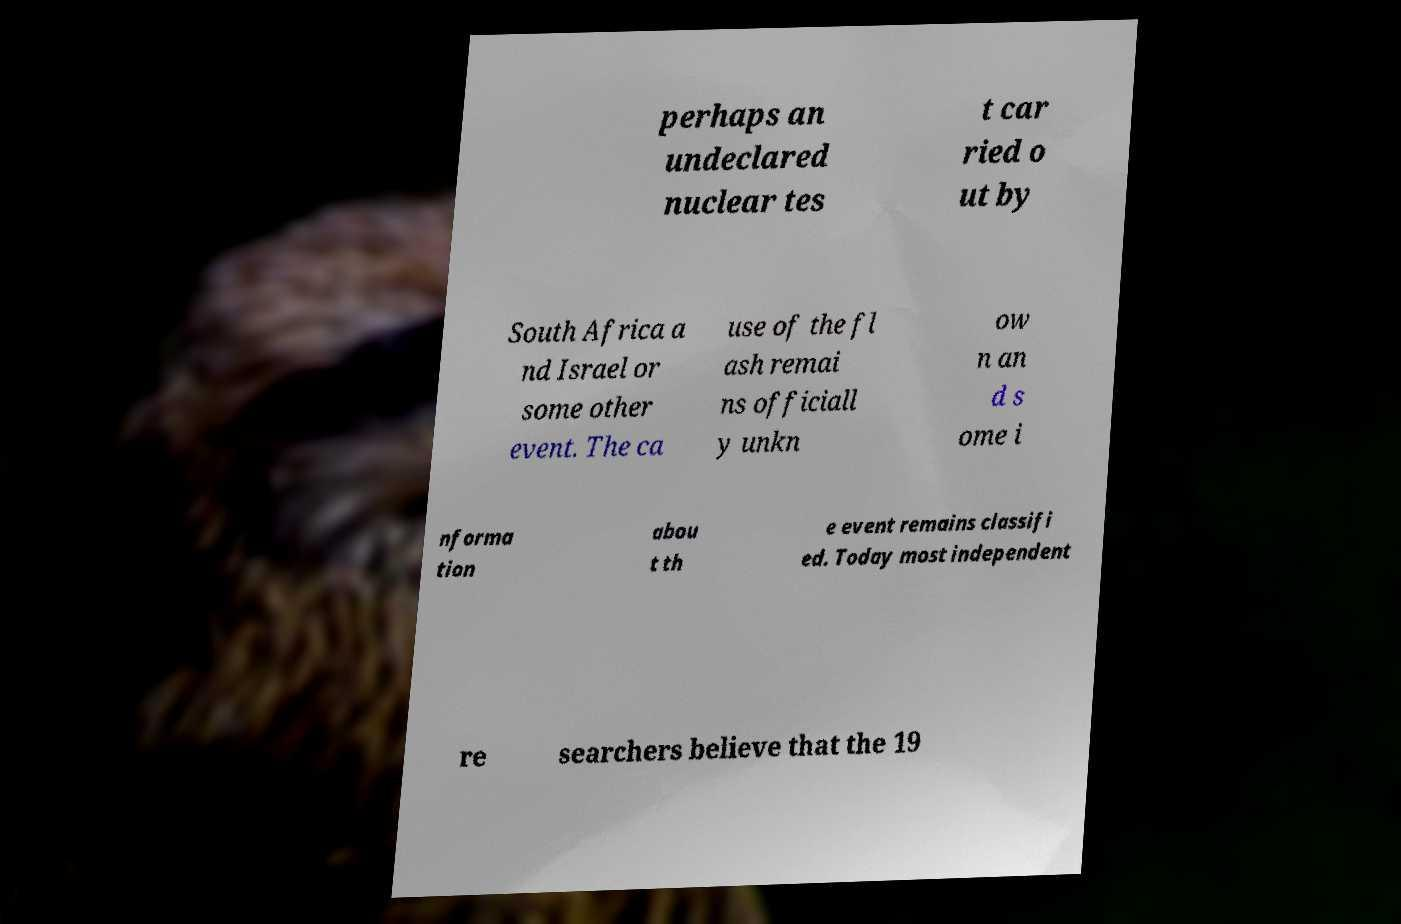Please read and relay the text visible in this image. What does it say? perhaps an undeclared nuclear tes t car ried o ut by South Africa a nd Israel or some other event. The ca use of the fl ash remai ns officiall y unkn ow n an d s ome i nforma tion abou t th e event remains classifi ed. Today most independent re searchers believe that the 19 